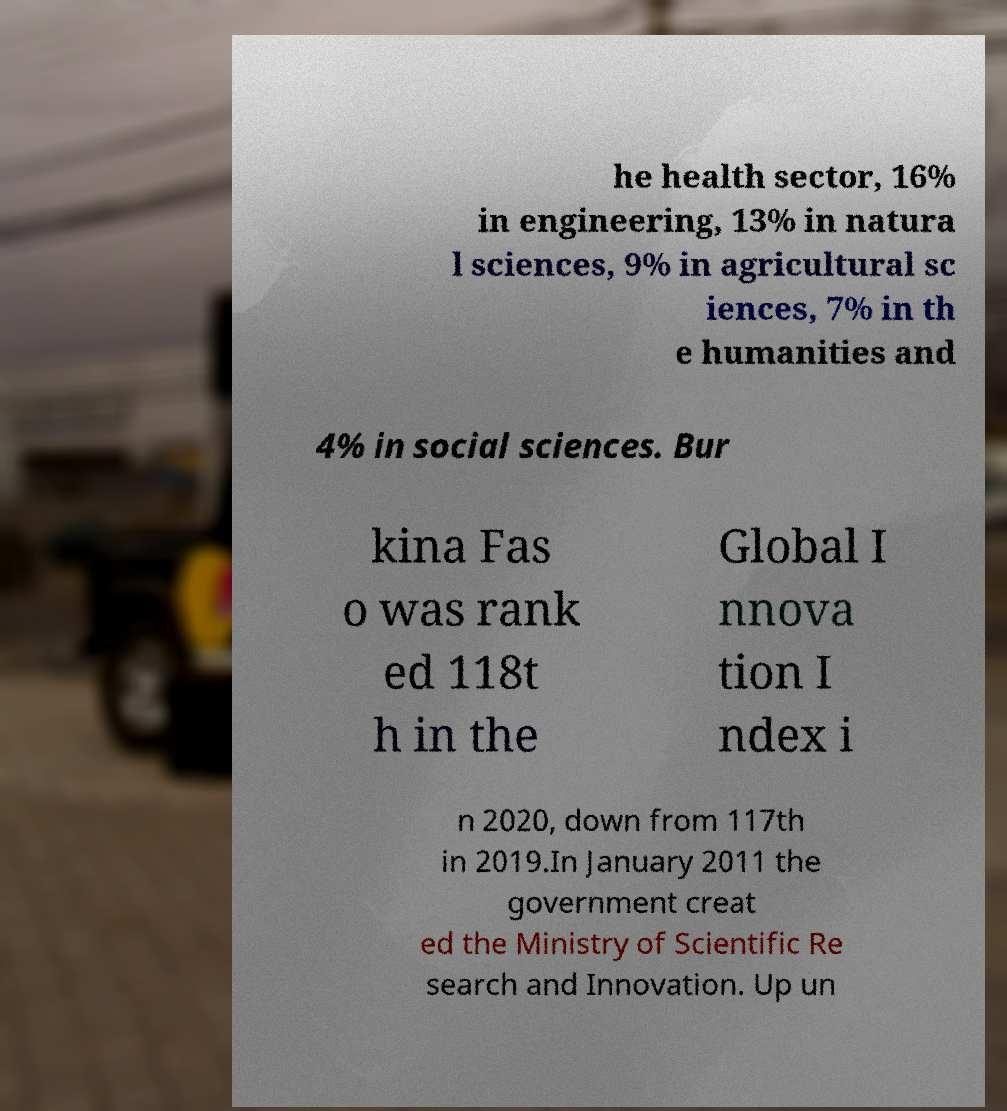Please identify and transcribe the text found in this image. he health sector, 16% in engineering, 13% in natura l sciences, 9% in agricultural sc iences, 7% in th e humanities and 4% in social sciences. Bur kina Fas o was rank ed 118t h in the Global I nnova tion I ndex i n 2020, down from 117th in 2019.In January 2011 the government creat ed the Ministry of Scientific Re search and Innovation. Up un 